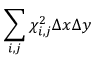Convert formula to latex. <formula><loc_0><loc_0><loc_500><loc_500>\sum _ { i , j } \chi _ { i , j } ^ { 2 } \Delta x \Delta y</formula> 